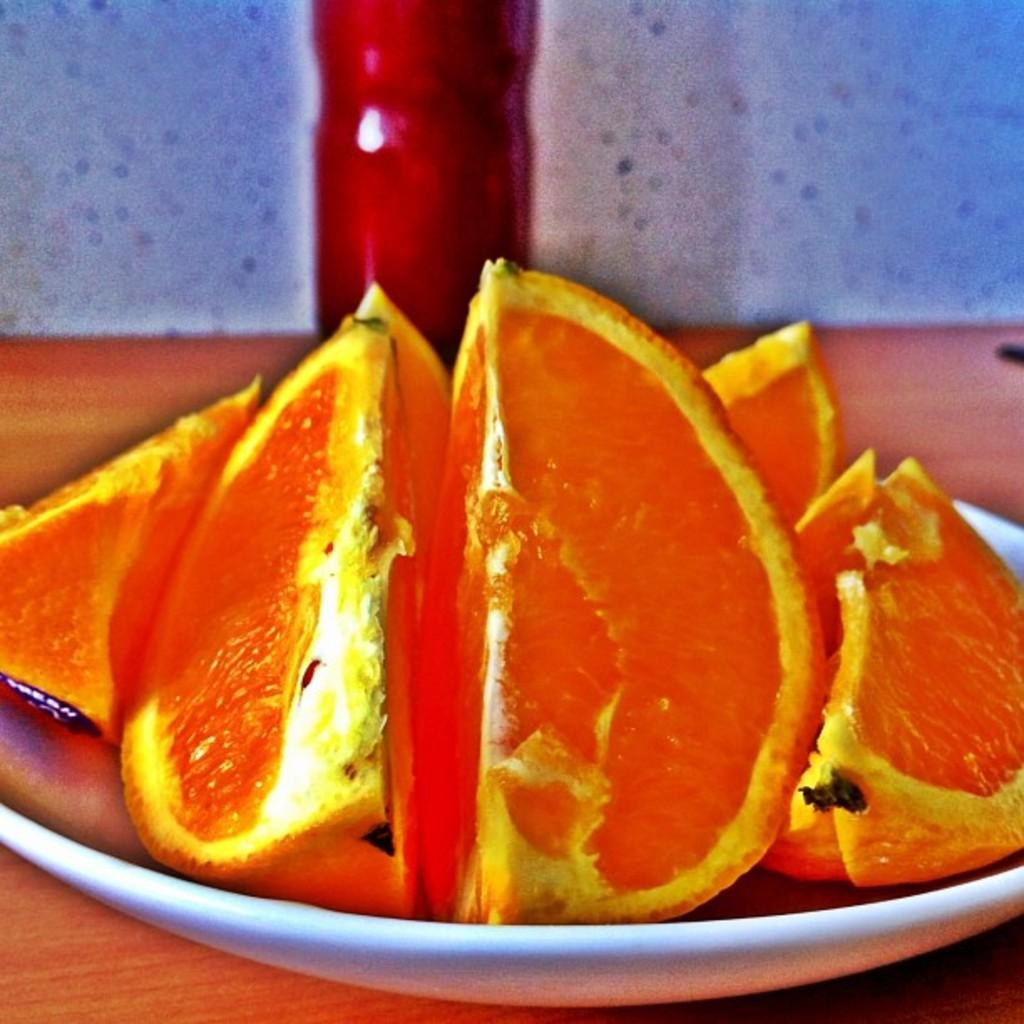What is on the plate that is visible in the image? There is a plate containing orange slices in the image. What else can be seen on the table in the image? There is a bottle placed on the table in the image. What is visible in the background of the image? There is a wall in the background of the image. What type of mist can be seen surrounding the orange slices in the image? There is no mist present in the image; it is a plate of orange slices with a bottle on the table and a wall in the background. 